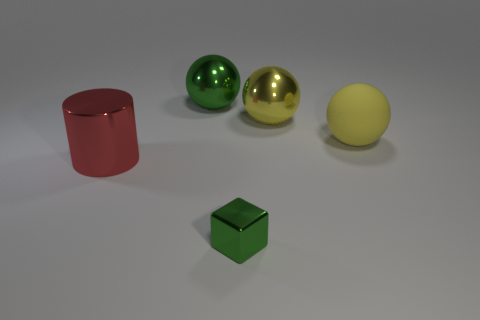Subtract all shiny balls. How many balls are left? 1 Subtract all yellow balls. How many balls are left? 1 Subtract all blocks. How many objects are left? 4 Subtract 1 cubes. How many cubes are left? 0 Add 4 small green blocks. How many small green blocks are left? 5 Add 4 small purple spheres. How many small purple spheres exist? 4 Add 4 shiny cylinders. How many objects exist? 9 Subtract 0 purple cylinders. How many objects are left? 5 Subtract all green spheres. Subtract all cyan cubes. How many spheres are left? 2 Subtract all red blocks. How many blue cylinders are left? 0 